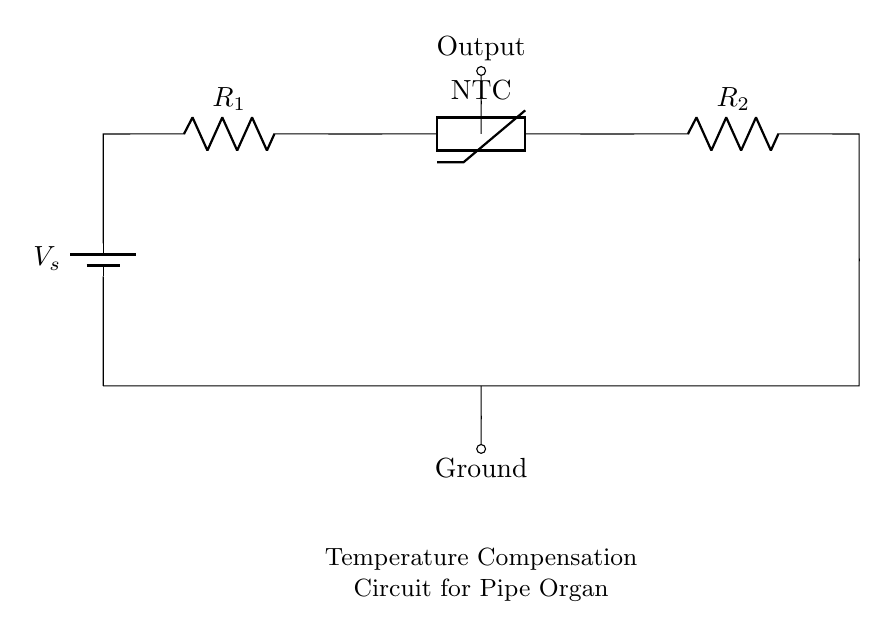What type of thermistor is used in the circuit? The circuit uses a negative temperature coefficient thermistor, which means its resistance decreases as the temperature rises. This is indicated by the label "NTC" in the circuit diagram.
Answer: NTC What is the function of the resistor labeled R1? Resistor R1 is part of the voltage divider arrangement that helps in measuring the voltage across the thermistor. It helps shape the response of the circuit based on temperature changes.
Answer: Voltage divider What is the output connection labeled as in the circuit? The output connection is positioned above the thermistor and is labeled as "Output," serving as the point where the adjusted voltage signal can be accessed.
Answer: Output What happens to the resistance of the thermistor when the temperature increases? The resistance of an NTC thermistor decreases when the temperature increases, which is its defining characteristic and can be deduced from the circuit's configuration.
Answer: Decreases Which component is connected directly to the power source? The power source, represented by the battery, is connected directly to resistor R1, establishing the starting point of the circuit path.
Answer: Resistor R1 What does the circuit primarily compensate for? The circuit is designed to compensate for temperature variations in a pipe organ, specifically adjusting the output based on temperature fluctuations to ensure consistent performance.
Answer: Temperature variations 